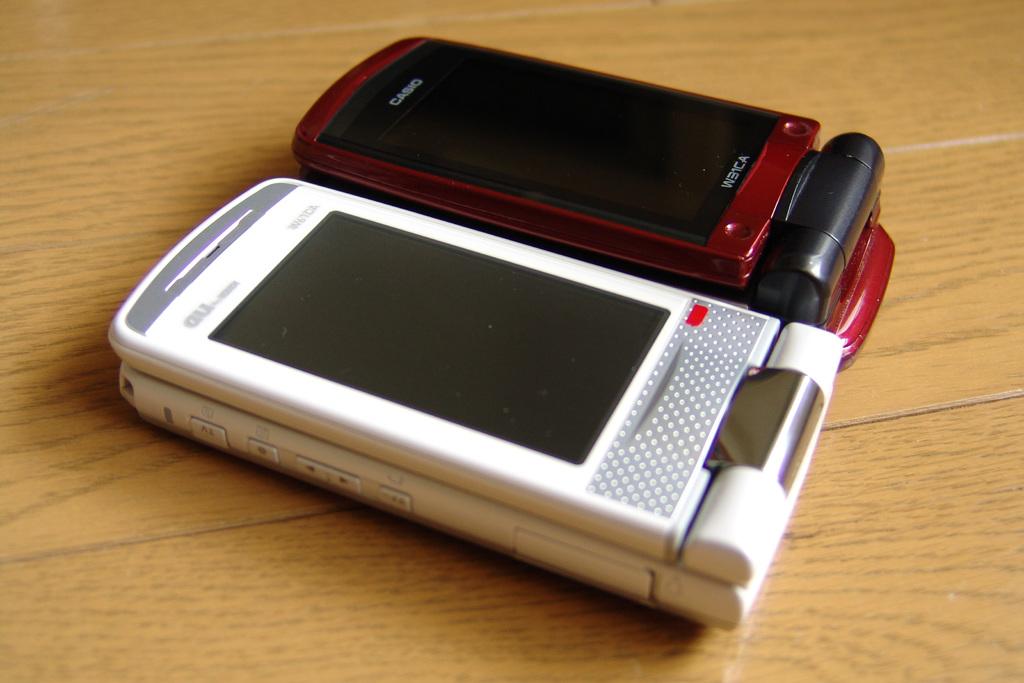What brand is that phone?
Your answer should be very brief. Casio. 